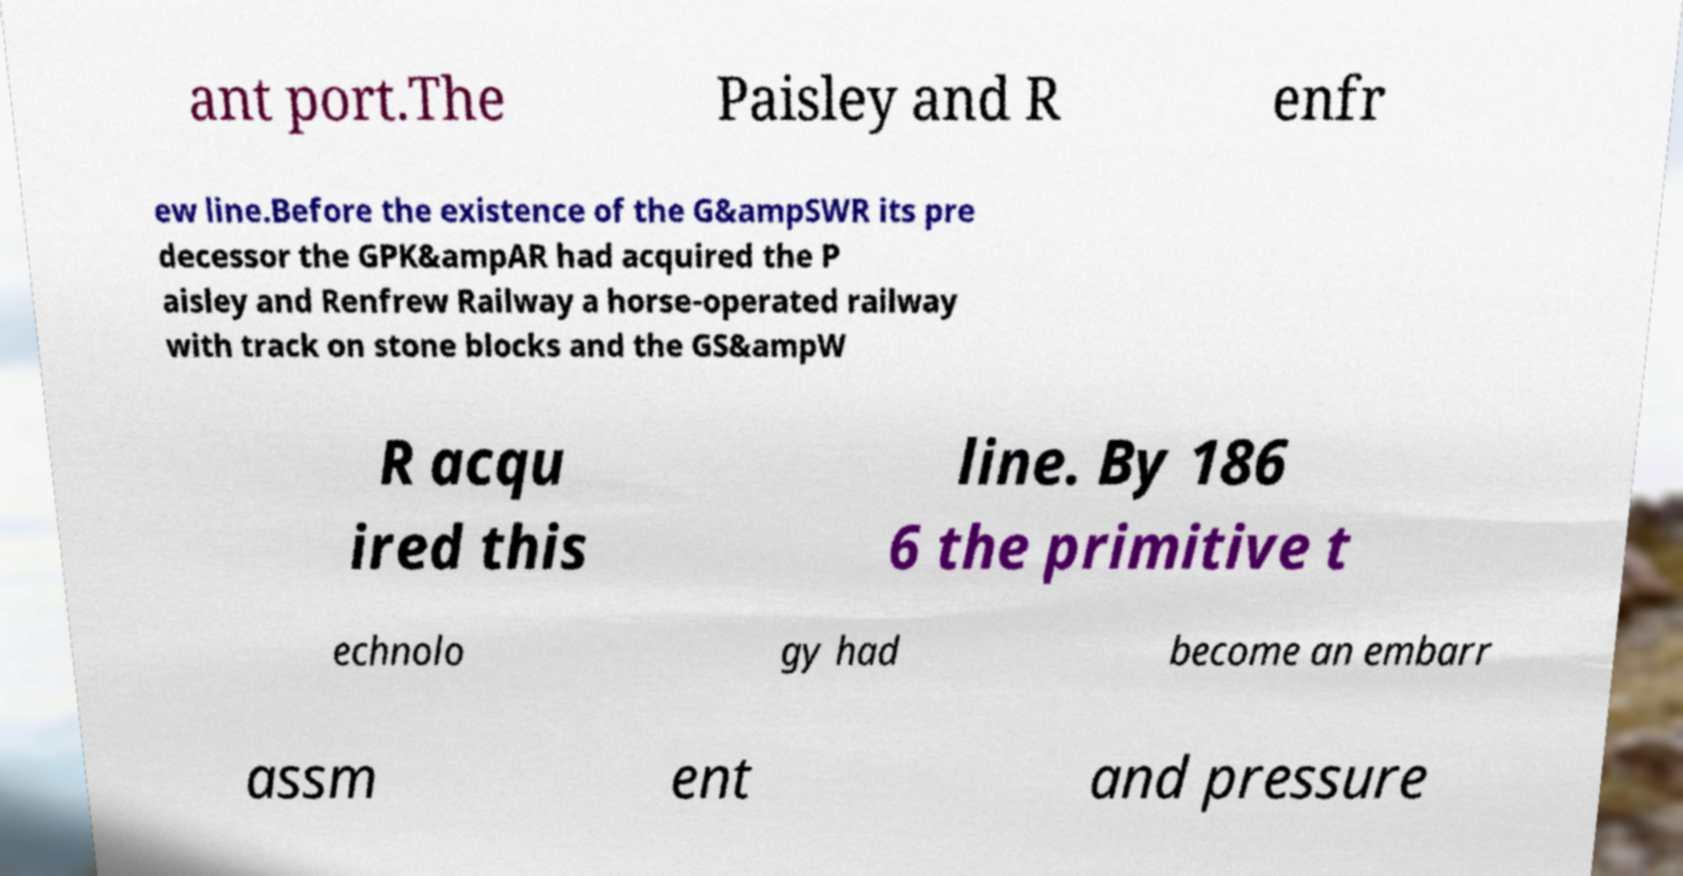Could you assist in decoding the text presented in this image and type it out clearly? ant port.The Paisley and R enfr ew line.Before the existence of the G&ampSWR its pre decessor the GPK&ampAR had acquired the P aisley and Renfrew Railway a horse-operated railway with track on stone blocks and the GS&ampW R acqu ired this line. By 186 6 the primitive t echnolo gy had become an embarr assm ent and pressure 